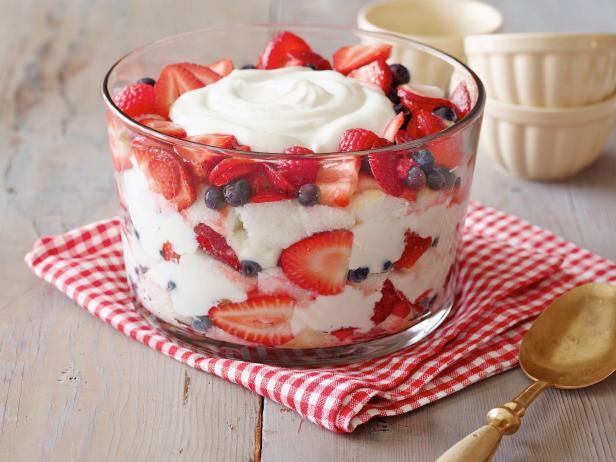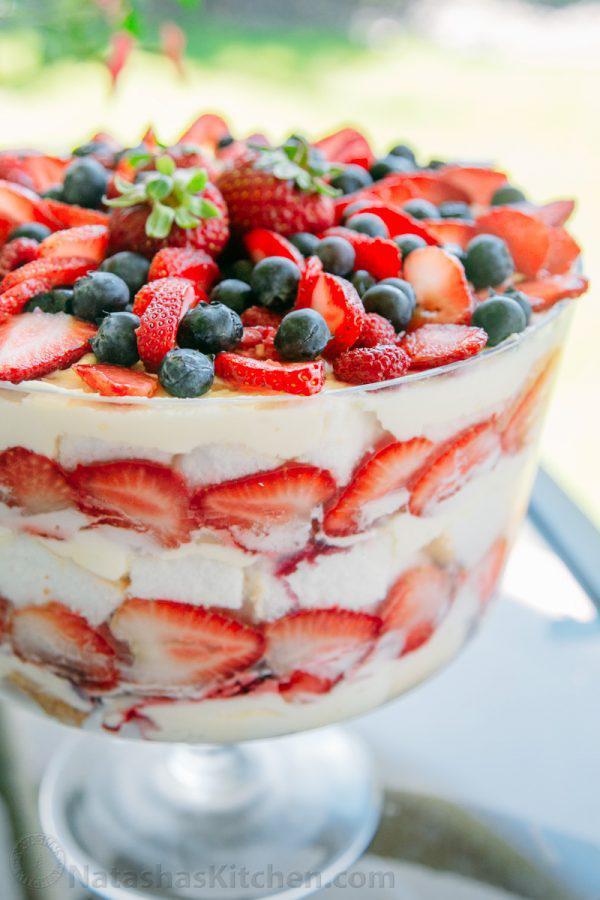The first image is the image on the left, the second image is the image on the right. Analyze the images presented: Is the assertion "There is an eating utensil next to a bowl of dessert." valid? Answer yes or no. Yes. The first image is the image on the left, the second image is the image on the right. For the images displayed, is the sentence "A dessert is garnished with blueberries, strawberry slices, and a few strawberries with their leafy green caps intact." factually correct? Answer yes or no. Yes. 